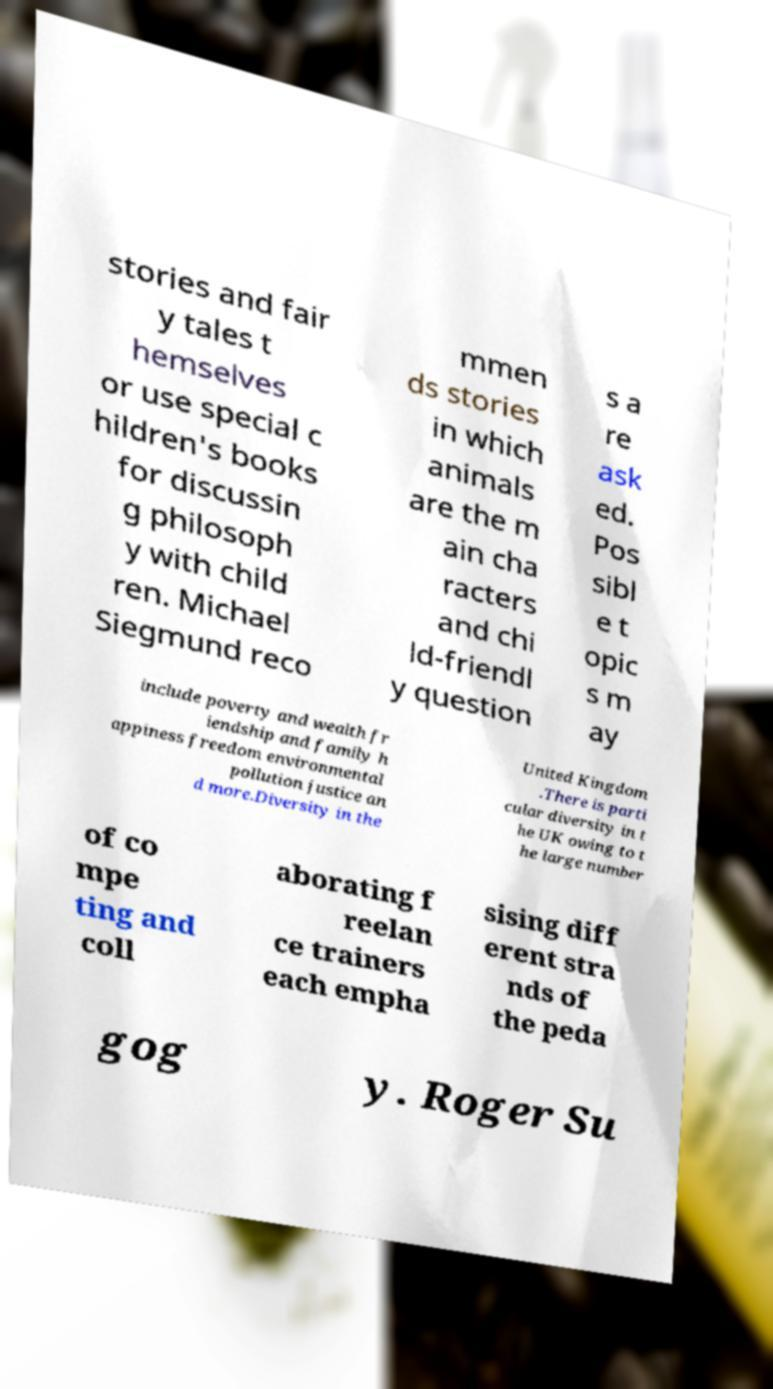For documentation purposes, I need the text within this image transcribed. Could you provide that? stories and fair y tales t hemselves or use special c hildren's books for discussin g philosoph y with child ren. Michael Siegmund reco mmen ds stories in which animals are the m ain cha racters and chi ld-friendl y question s a re ask ed. Pos sibl e t opic s m ay include poverty and wealth fr iendship and family h appiness freedom environmental pollution justice an d more.Diversity in the United Kingdom .There is parti cular diversity in t he UK owing to t he large number of co mpe ting and coll aborating f reelan ce trainers each empha sising diff erent stra nds of the peda gog y. Roger Su 